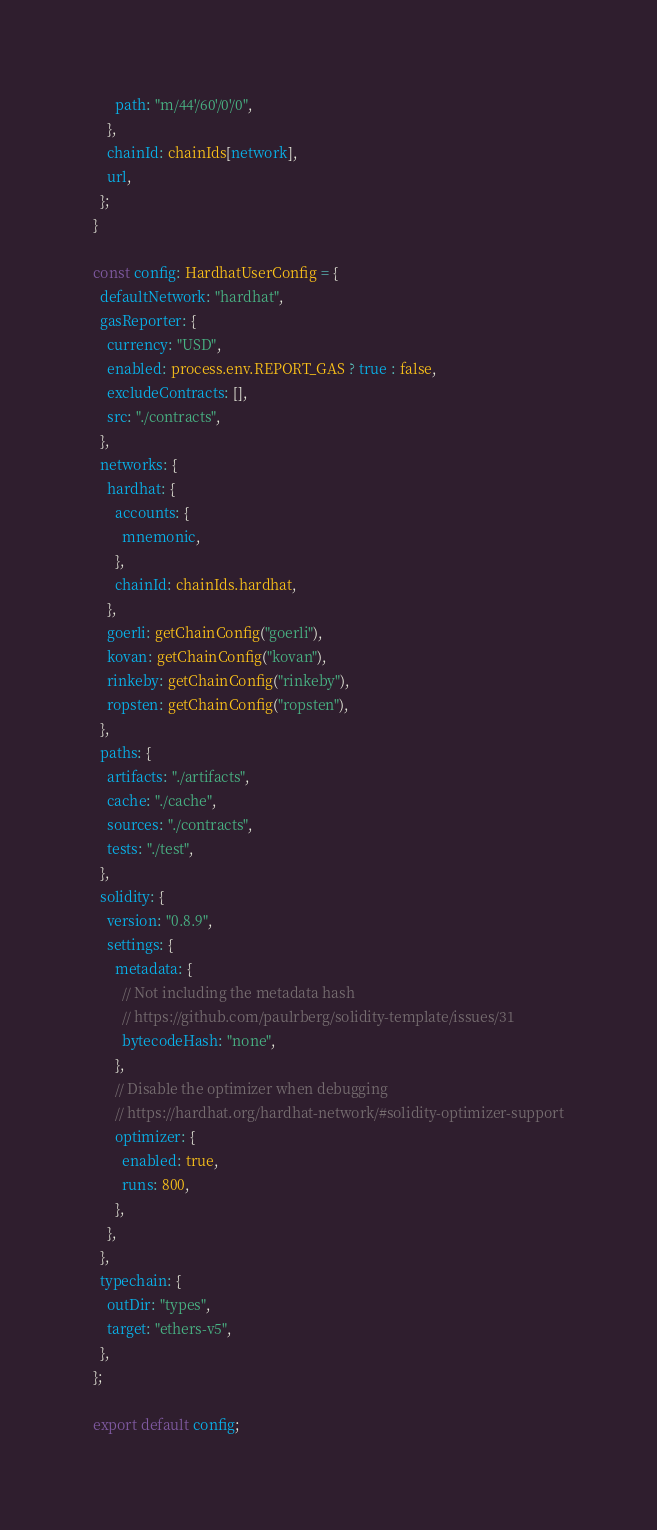Convert code to text. <code><loc_0><loc_0><loc_500><loc_500><_TypeScript_>      path: "m/44'/60'/0'/0",
    },
    chainId: chainIds[network],
    url,
  };
}

const config: HardhatUserConfig = {
  defaultNetwork: "hardhat",
  gasReporter: {
    currency: "USD",
    enabled: process.env.REPORT_GAS ? true : false,
    excludeContracts: [],
    src: "./contracts",
  },
  networks: {
    hardhat: {
      accounts: {
        mnemonic,
      },
      chainId: chainIds.hardhat,
    },
    goerli: getChainConfig("goerli"),
    kovan: getChainConfig("kovan"),
    rinkeby: getChainConfig("rinkeby"),
    ropsten: getChainConfig("ropsten"),
  },
  paths: {
    artifacts: "./artifacts",
    cache: "./cache",
    sources: "./contracts",
    tests: "./test",
  },
  solidity: {
    version: "0.8.9",
    settings: {
      metadata: {
        // Not including the metadata hash
        // https://github.com/paulrberg/solidity-template/issues/31
        bytecodeHash: "none",
      },
      // Disable the optimizer when debugging
      // https://hardhat.org/hardhat-network/#solidity-optimizer-support
      optimizer: {
        enabled: true,
        runs: 800,
      },
    },
  },
  typechain: {
    outDir: "types",
    target: "ethers-v5",
  },
};

export default config;
</code> 